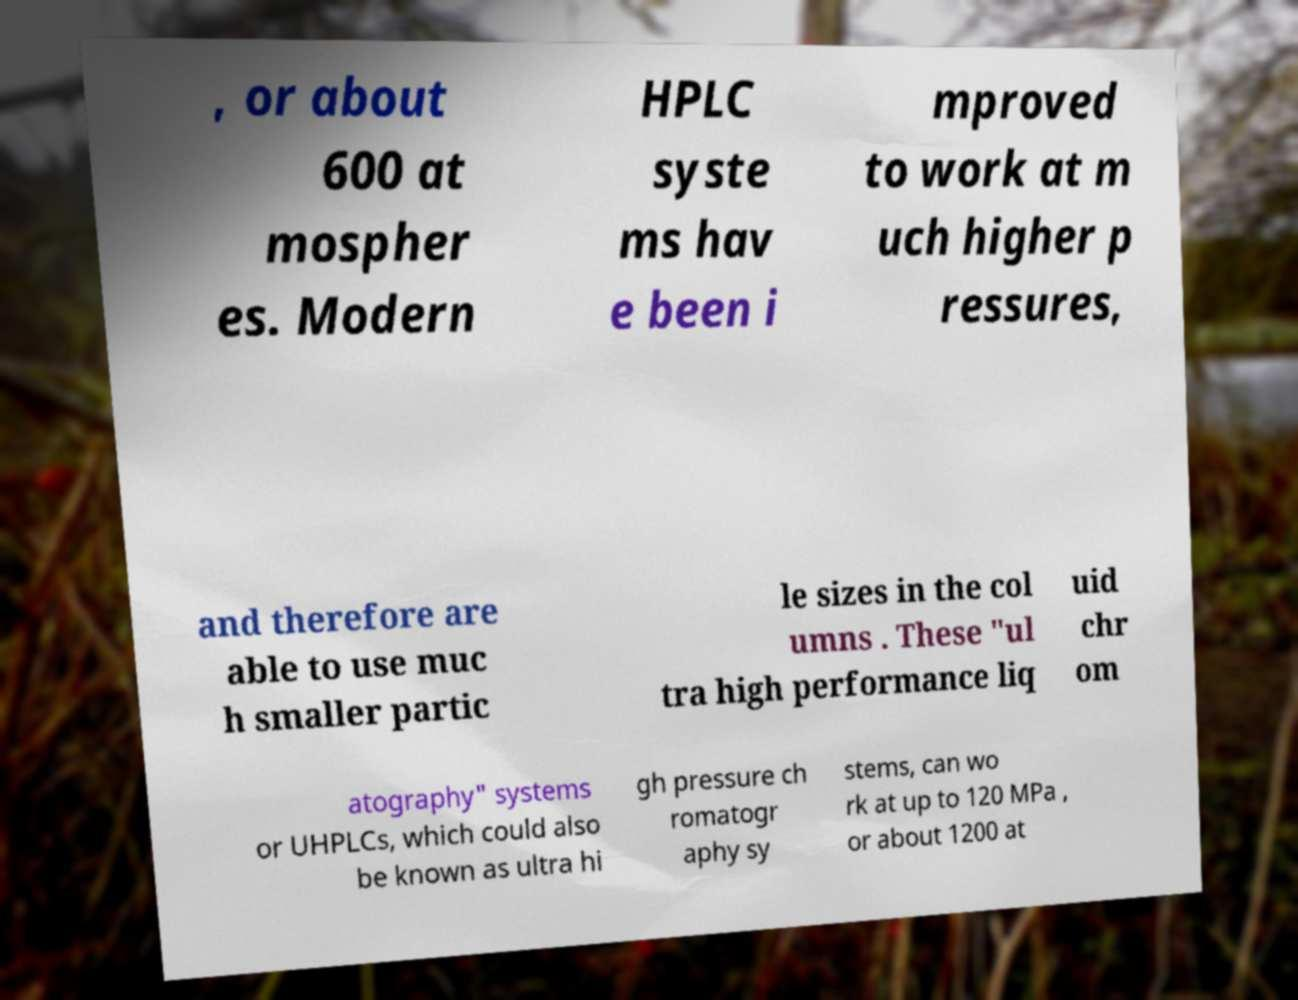Could you extract and type out the text from this image? , or about 600 at mospher es. Modern HPLC syste ms hav e been i mproved to work at m uch higher p ressures, and therefore are able to use muc h smaller partic le sizes in the col umns . These "ul tra high performance liq uid chr om atography" systems or UHPLCs, which could also be known as ultra hi gh pressure ch romatogr aphy sy stems, can wo rk at up to 120 MPa , or about 1200 at 